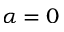Convert formula to latex. <formula><loc_0><loc_0><loc_500><loc_500>\alpha = 0</formula> 